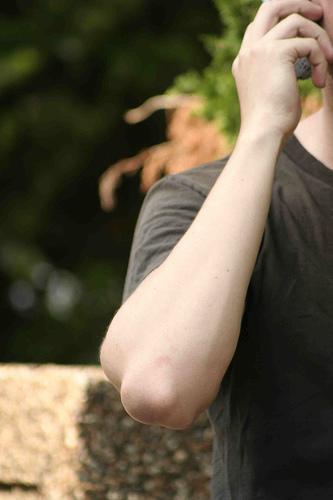How many people are pictured here?
Give a very brief answer. 1. How many animals are in this picture?
Give a very brief answer. 0. 